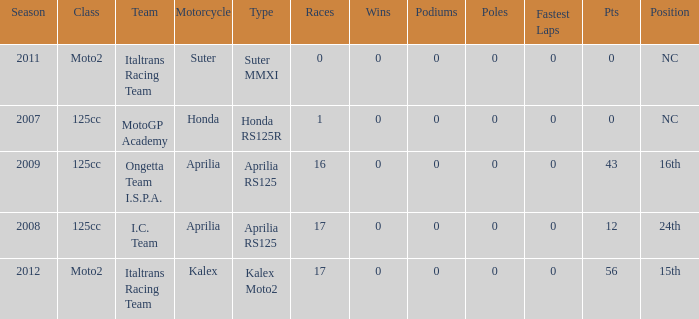How many fastest laps did I.C. Team have? 1.0. 